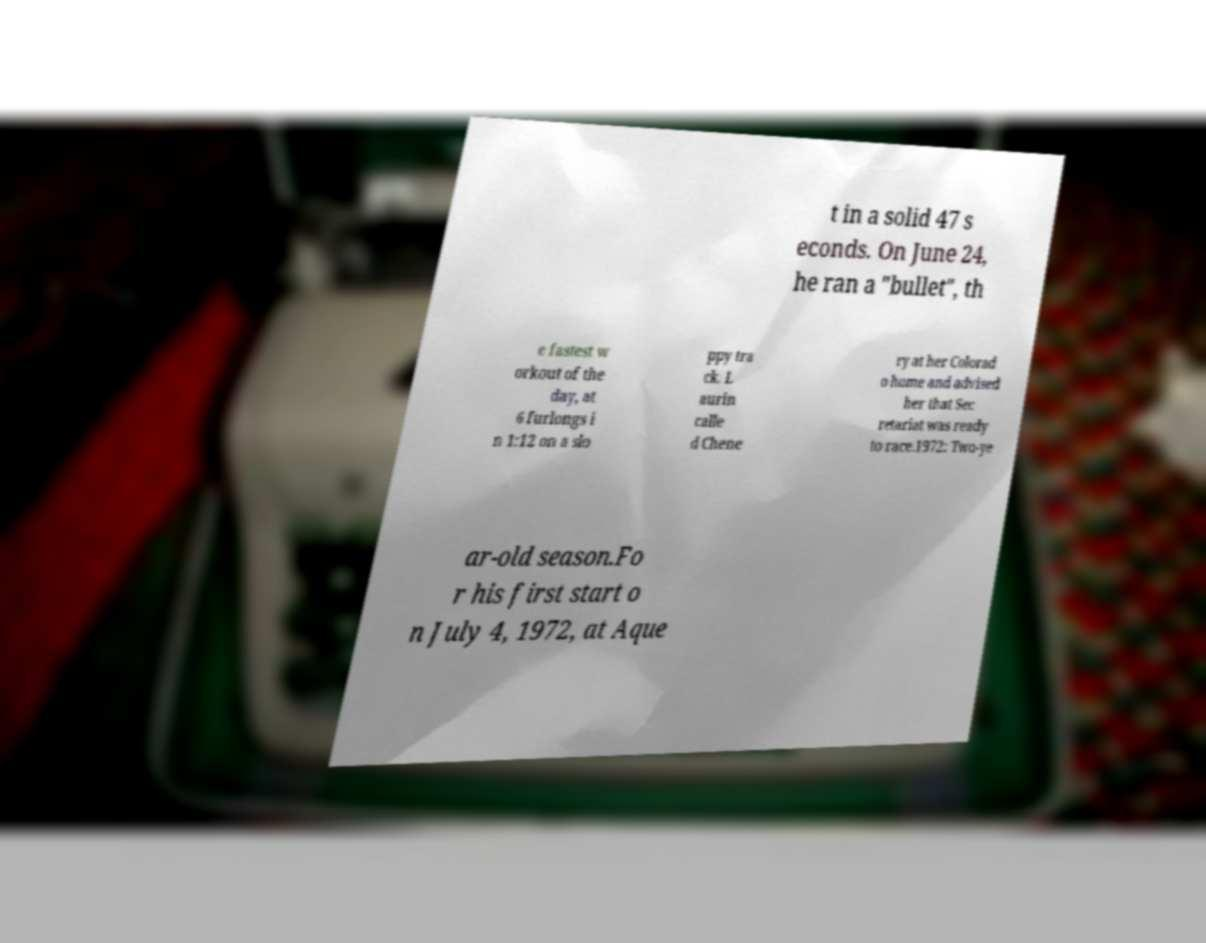What messages or text are displayed in this image? I need them in a readable, typed format. t in a solid 47 s econds. On June 24, he ran a "bullet", th e fastest w orkout of the day, at 6 furlongs i n 1:12 on a slo ppy tra ck. L aurin calle d Chene ry at her Colorad o home and advised her that Sec retariat was ready to race.1972: Two-ye ar-old season.Fo r his first start o n July 4, 1972, at Aque 